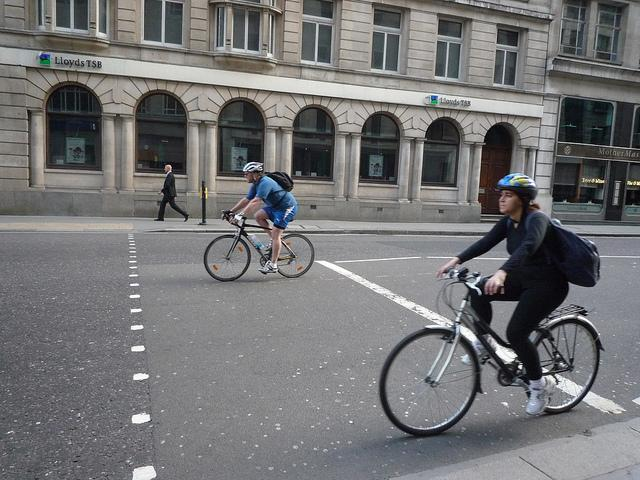When did two companies merge into this one bank? 1995 